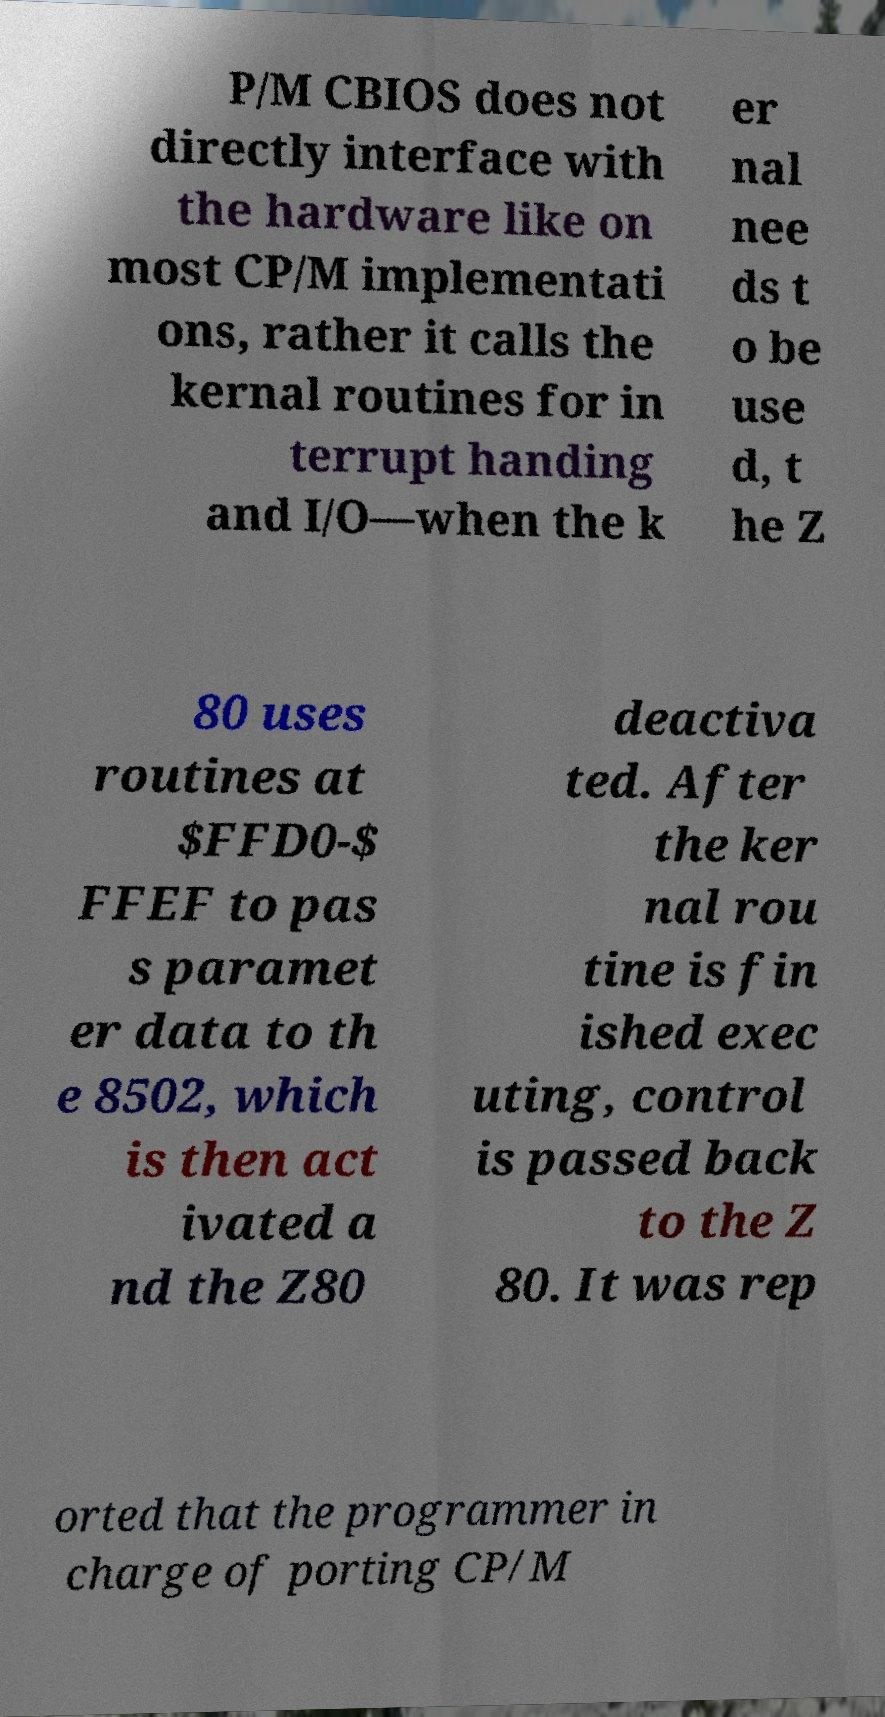Can you read and provide the text displayed in the image?This photo seems to have some interesting text. Can you extract and type it out for me? P/M CBIOS does not directly interface with the hardware like on most CP/M implementati ons, rather it calls the kernal routines for in terrupt handing and I/O—when the k er nal nee ds t o be use d, t he Z 80 uses routines at $FFD0-$ FFEF to pas s paramet er data to th e 8502, which is then act ivated a nd the Z80 deactiva ted. After the ker nal rou tine is fin ished exec uting, control is passed back to the Z 80. It was rep orted that the programmer in charge of porting CP/M 